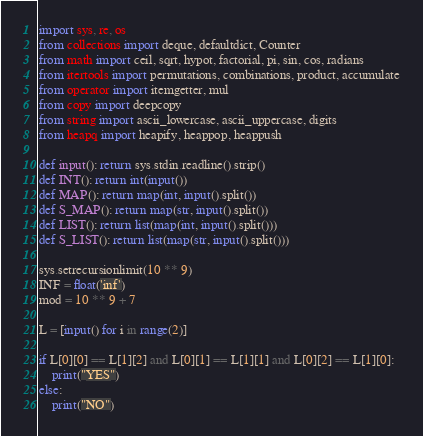<code> <loc_0><loc_0><loc_500><loc_500><_Python_>import sys, re, os
from collections import deque, defaultdict, Counter
from math import ceil, sqrt, hypot, factorial, pi, sin, cos, radians
from itertools import permutations, combinations, product, accumulate
from operator import itemgetter, mul
from copy import deepcopy
from string import ascii_lowercase, ascii_uppercase, digits
from heapq import heapify, heappop, heappush
 
def input(): return sys.stdin.readline().strip()
def INT(): return int(input())
def MAP(): return map(int, input().split())
def S_MAP(): return map(str, input().split())
def LIST(): return list(map(int, input().split()))
def S_LIST(): return list(map(str, input().split()))
 
sys.setrecursionlimit(10 ** 9)
INF = float('inf')
mod = 10 ** 9 + 7

L = [input() for i in range(2)]

if L[0][0] == L[1][2] and L[0][1] == L[1][1] and L[0][2] == L[1][0]:
    print("YES")
else:
    print("NO")</code> 